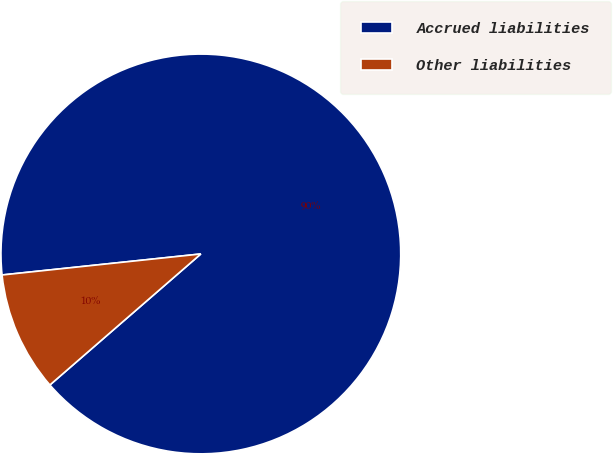Convert chart. <chart><loc_0><loc_0><loc_500><loc_500><pie_chart><fcel>Accrued liabilities<fcel>Other liabilities<nl><fcel>90.3%<fcel>9.7%<nl></chart> 